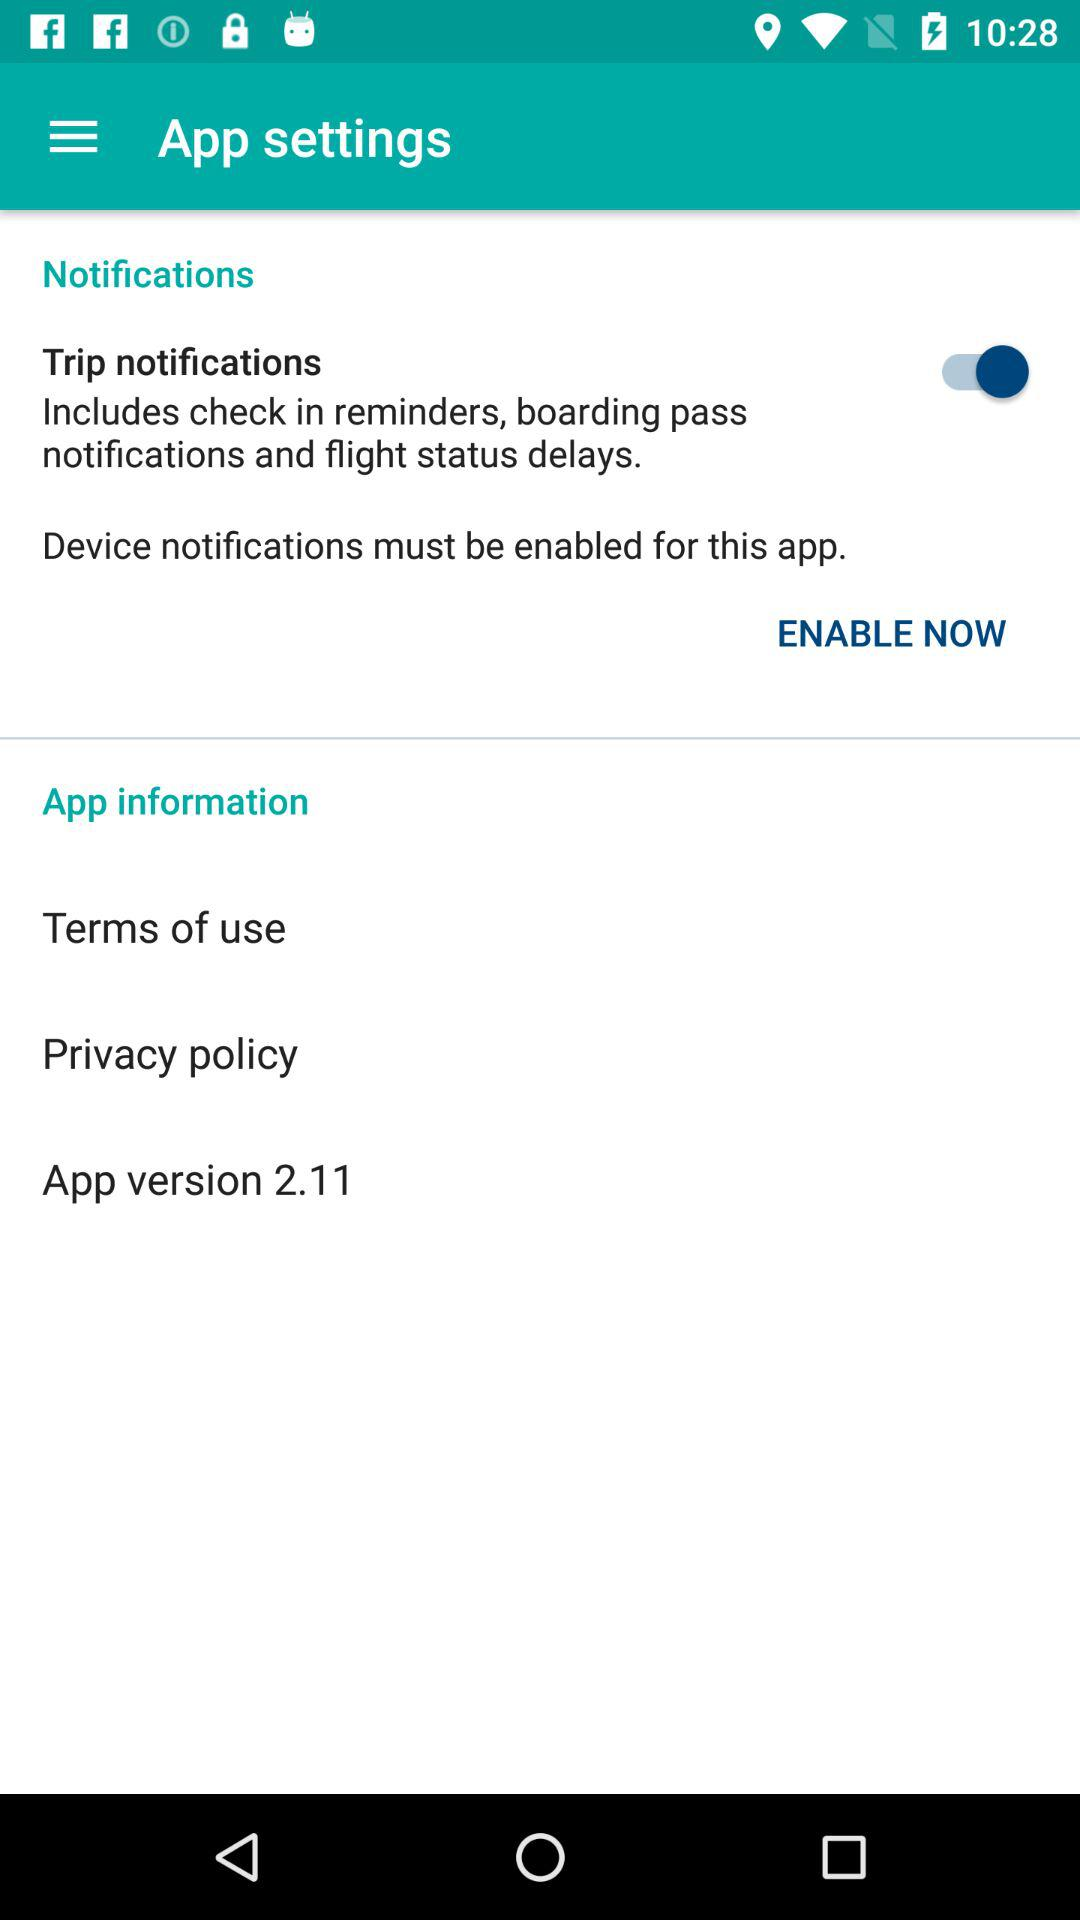What is the app version? The app version is 2.11. 